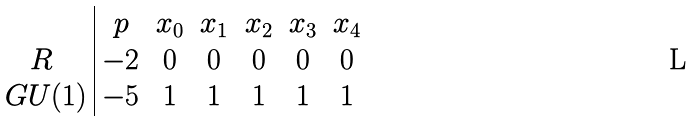<formula> <loc_0><loc_0><loc_500><loc_500>\begin{array} { c | c c c c c c } & p & x _ { 0 } & x _ { 1 } & x _ { 2 } & x _ { 3 } & x _ { 4 } \\ R & - 2 & 0 & 0 & 0 & 0 & 0 \\ \ G U ( 1 ) & - 5 & 1 & 1 & 1 & 1 & 1 \end{array}</formula> 